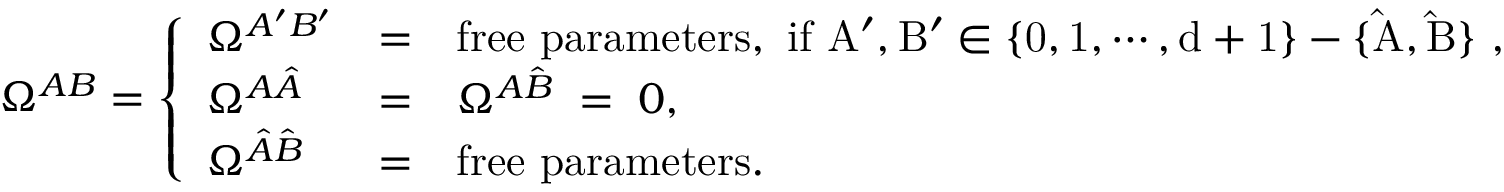Convert formula to latex. <formula><loc_0><loc_0><loc_500><loc_500>\Omega ^ { A B } = \left \{ \begin{array} { l l l } { { \Omega ^ { A ^ { \prime } B ^ { \prime } } } } & { = } & { { f r e e p a r a m e t e r s , i f A ^ { \prime } , B ^ { \prime } \in \{ 0 , 1 , \cdots , d + 1 \} - \{ \hat { A } , \hat { B } \} , } } \\ { { \Omega ^ { A \hat { A } } } } & { = } & { { \Omega ^ { A \hat { B } } \, = \, 0 , } } \\ { { \Omega ^ { \hat { A } \hat { B } } } } & { = } & { f r e e p a r a m e t e r s . } \end{array}</formula> 